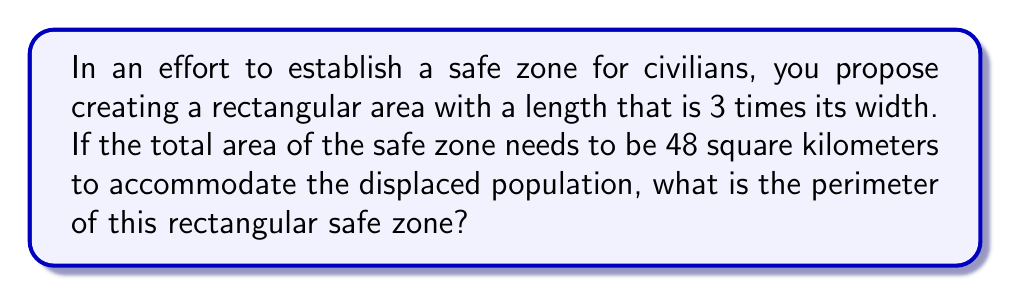Provide a solution to this math problem. Let's approach this step-by-step:

1) Let the width of the rectangle be $w$ km and the length be $l$ km.

2) Given that the length is 3 times the width:
   $l = 3w$

3) The area of a rectangle is given by length times width:
   $A = l \times w$
   $48 = 3w \times w = 3w^2$

4) Solve for $w$:
   $w^2 = 48 \div 3 = 16$
   $w = \sqrt{16} = 4$ km

5) If $w = 4$ km, then $l = 3w = 3 \times 4 = 12$ km

6) The perimeter of a rectangle is given by the formula:
   $P = 2l + 2w$

7) Substitute the values:
   $P = 2(12) + 2(4) = 24 + 8 = 32$ km

Therefore, the perimeter of the rectangular safe zone is 32 kilometers.
Answer: $32$ km 